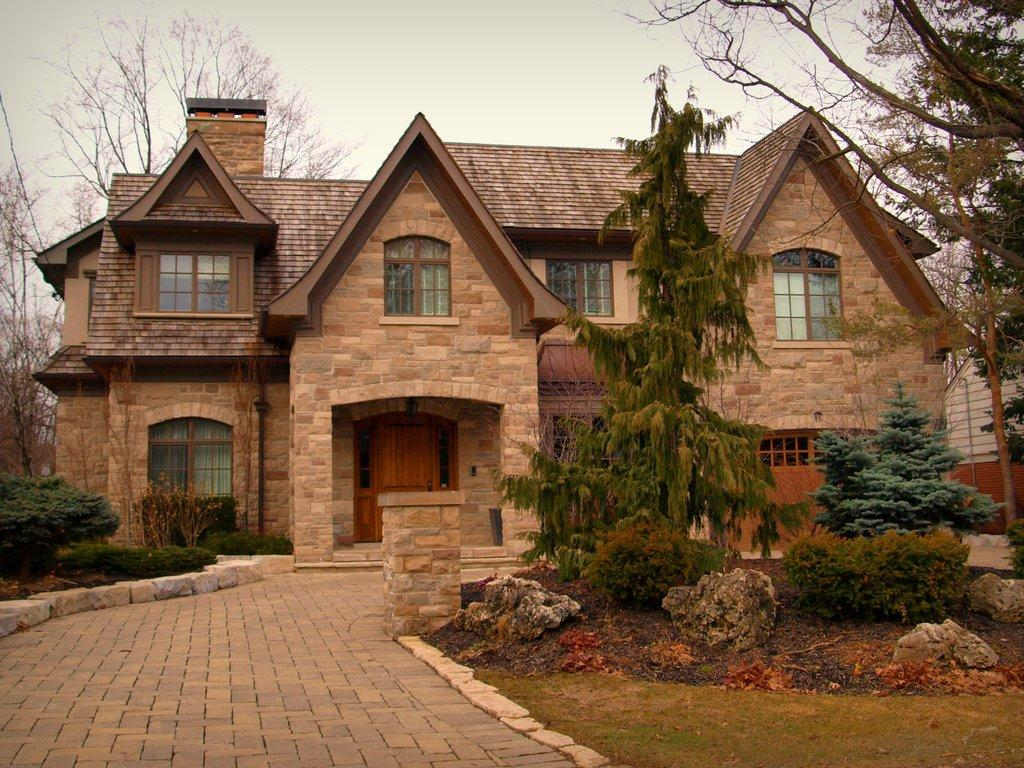What type of surface is visible in the image? There is a pavement in the image. What can be seen in the background of the image? There are trees, a house, and the sky visible in the background of the image. What type of credit card is being used to purchase the house in the image? There is no credit card or purchase of a house depicted in the image. What kind of toy can be seen in the hands of the person walking on the pavement? There is no person or toy present in the image. 